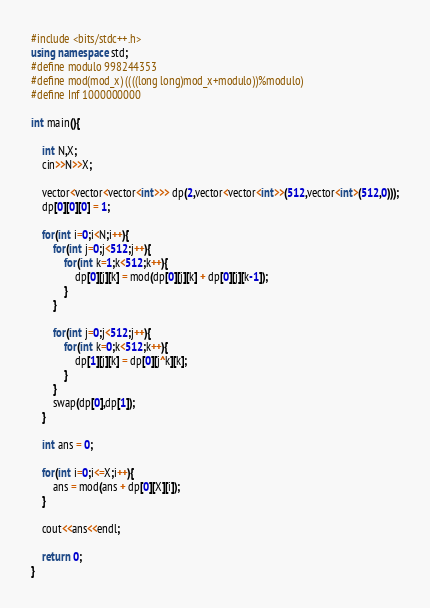<code> <loc_0><loc_0><loc_500><loc_500><_C++_>#include <bits/stdc++.h>
using namespace std;
#define modulo 998244353
#define mod(mod_x) ((((long long)mod_x+modulo))%modulo)
#define Inf 1000000000

int main(){
    
	int N,X;
	cin>>N>>X;
	
	vector<vector<vector<int>>> dp(2,vector<vector<int>>(512,vector<int>(512,0)));
	dp[0][0][0] = 1;
	
	for(int i=0;i<N;i++){
		for(int j=0;j<512;j++){
			for(int k=1;k<512;k++){
				dp[0][j][k] = mod(dp[0][j][k] + dp[0][j][k-1]);
			}
		}
		
		for(int j=0;j<512;j++){
			for(int k=0;k<512;k++){
				dp[1][j][k] = dp[0][j^k][k];
			}
		}
		swap(dp[0],dp[1]);
	}
	
	int ans = 0;
	
	for(int i=0;i<=X;i++){
		ans = mod(ans + dp[0][X][i]);
	}
	
	cout<<ans<<endl;
	
    return 0;
}

</code> 